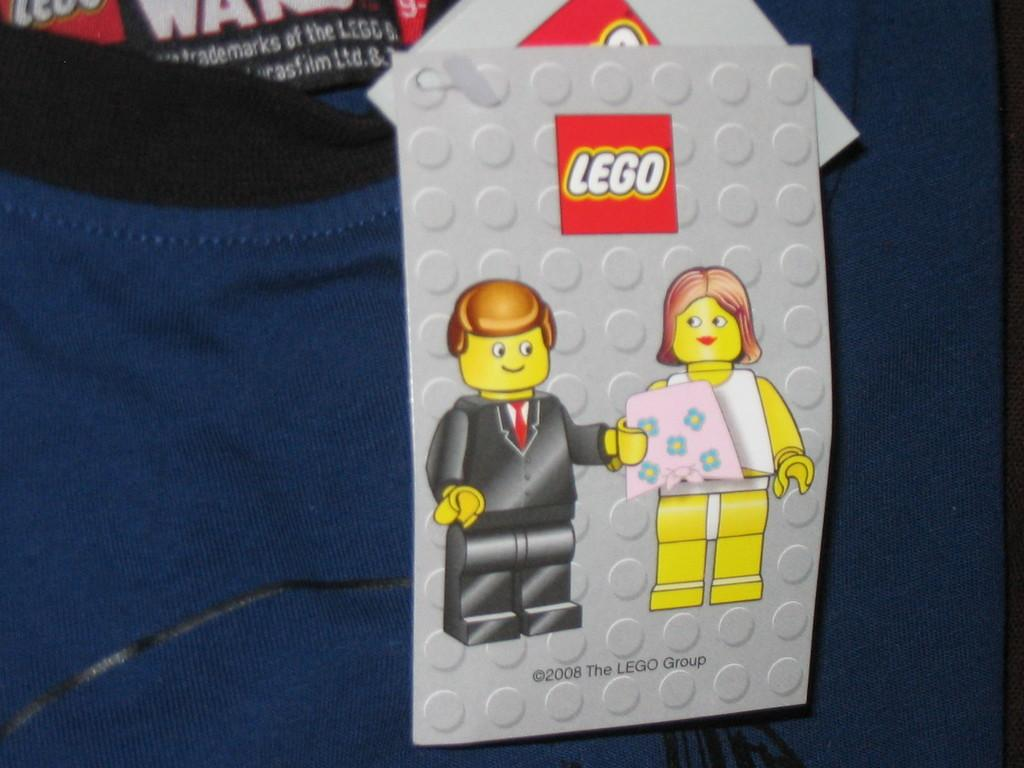<image>
Give a short and clear explanation of the subsequent image. A blue shirt with a black collar containing an attached tag that says Lego on top and 2008 The Lego Group on the bottom. 